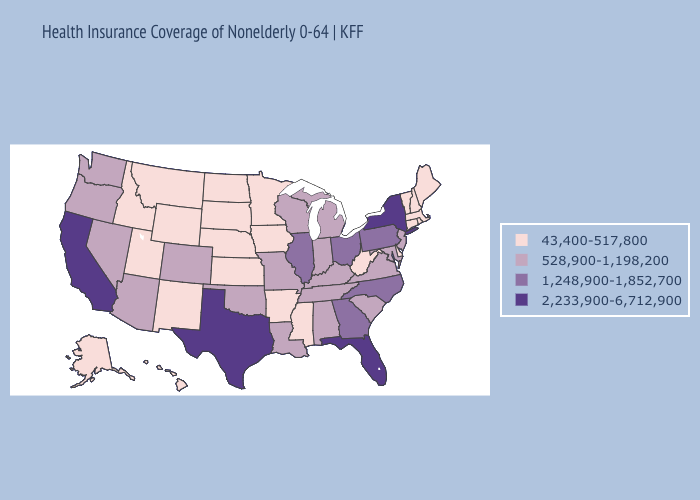What is the lowest value in states that border Nevada?
Short answer required. 43,400-517,800. Does New Mexico have the same value as Washington?
Be succinct. No. What is the highest value in the USA?
Keep it brief. 2,233,900-6,712,900. Does Utah have the highest value in the USA?
Write a very short answer. No. Name the states that have a value in the range 1,248,900-1,852,700?
Write a very short answer. Georgia, Illinois, North Carolina, Ohio, Pennsylvania. What is the highest value in the USA?
Concise answer only. 2,233,900-6,712,900. Among the states that border Wisconsin , which have the lowest value?
Give a very brief answer. Iowa, Minnesota. What is the highest value in the USA?
Keep it brief. 2,233,900-6,712,900. Is the legend a continuous bar?
Answer briefly. No. What is the highest value in the USA?
Concise answer only. 2,233,900-6,712,900. What is the value of Mississippi?
Quick response, please. 43,400-517,800. Does Nevada have a higher value than Utah?
Quick response, please. Yes. What is the value of Virginia?
Give a very brief answer. 528,900-1,198,200. Among the states that border Indiana , which have the lowest value?
Be succinct. Kentucky, Michigan. Which states have the lowest value in the USA?
Give a very brief answer. Alaska, Arkansas, Connecticut, Delaware, Hawaii, Idaho, Iowa, Kansas, Maine, Massachusetts, Minnesota, Mississippi, Montana, Nebraska, New Hampshire, New Mexico, North Dakota, Rhode Island, South Dakota, Utah, Vermont, West Virginia, Wyoming. 